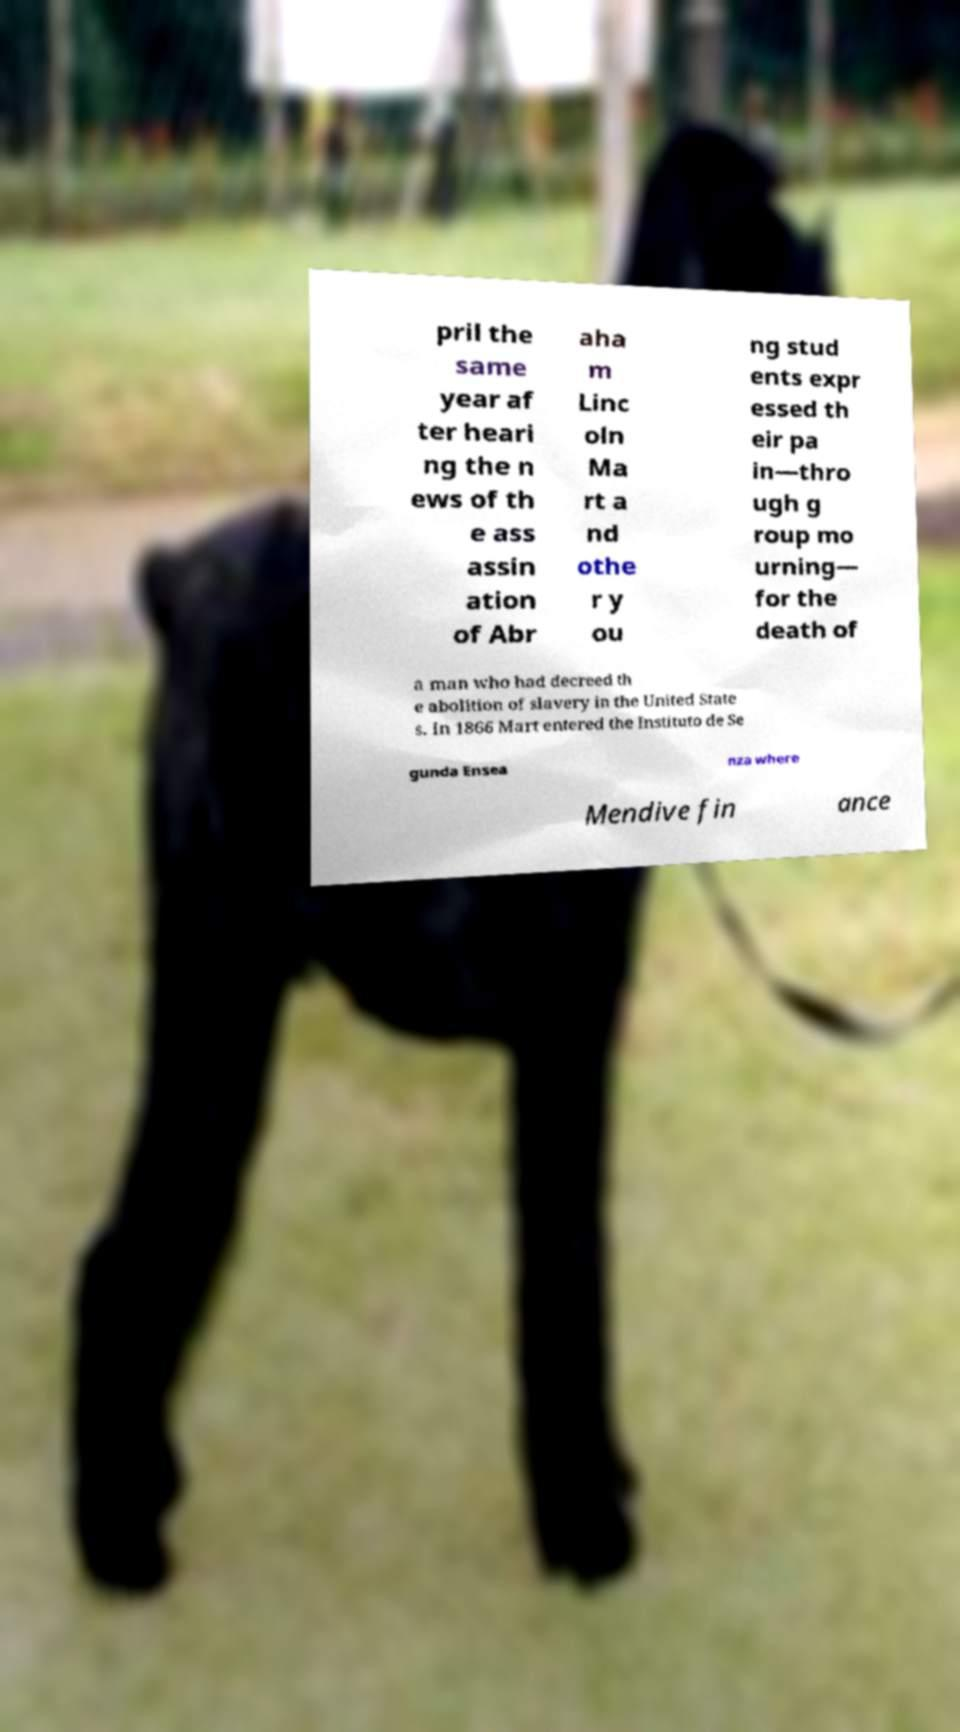Can you accurately transcribe the text from the provided image for me? pril the same year af ter heari ng the n ews of th e ass assin ation of Abr aha m Linc oln Ma rt a nd othe r y ou ng stud ents expr essed th eir pa in—thro ugh g roup mo urning— for the death of a man who had decreed th e abolition of slavery in the United State s. In 1866 Mart entered the Instituto de Se gunda Ensea nza where Mendive fin ance 